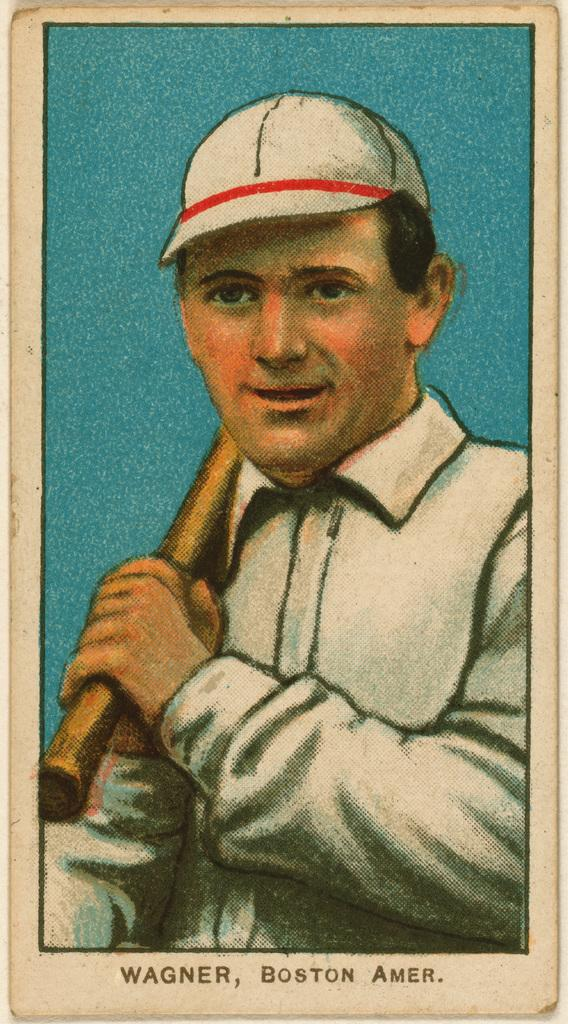What type of image is depicted in the picture? There is an animated image of a person in the image. What is the person wearing in the image? The person is wearing a white dress in the image. What is the person holding in the image? The person is holding an object with his hands in the image. What is the person's opinion on the expansion of the universe in the image? There is no indication in the image of the person's opinion on the expansion of the universe, as the image only shows an animated person holding an object. Is there any steam visible coming from the object the person is holding in the image? There is no steam visible in the image, as the focus is on the animated person and the object they are holding. 